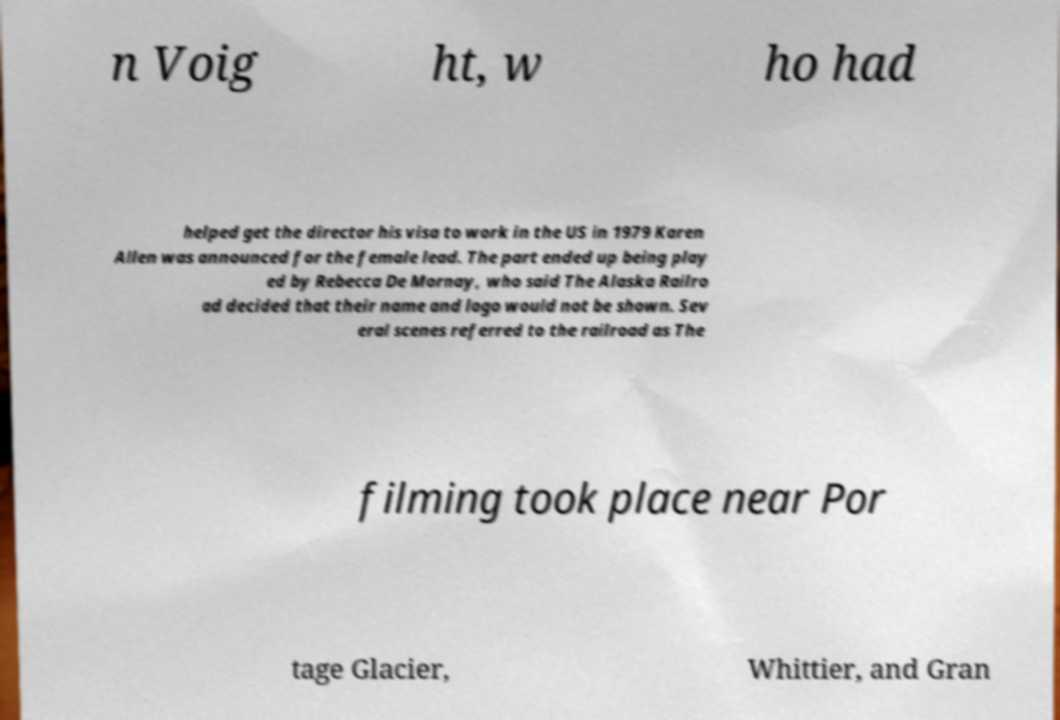Can you accurately transcribe the text from the provided image for me? n Voig ht, w ho had helped get the director his visa to work in the US in 1979 Karen Allen was announced for the female lead. The part ended up being play ed by Rebecca De Mornay, who said The Alaska Railro ad decided that their name and logo would not be shown. Sev eral scenes referred to the railroad as The filming took place near Por tage Glacier, Whittier, and Gran 